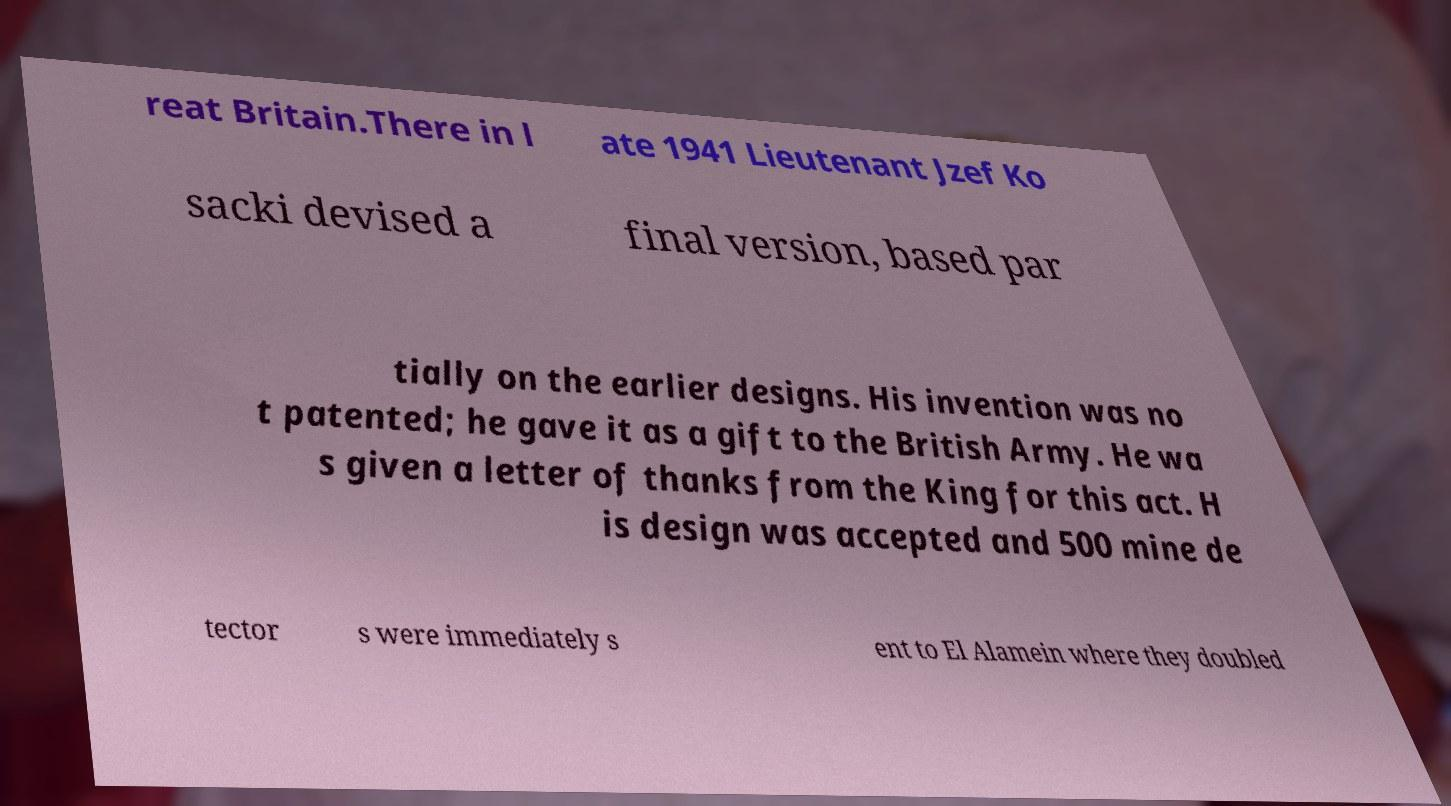Can you accurately transcribe the text from the provided image for me? reat Britain.There in l ate 1941 Lieutenant Jzef Ko sacki devised a final version, based par tially on the earlier designs. His invention was no t patented; he gave it as a gift to the British Army. He wa s given a letter of thanks from the King for this act. H is design was accepted and 500 mine de tector s were immediately s ent to El Alamein where they doubled 